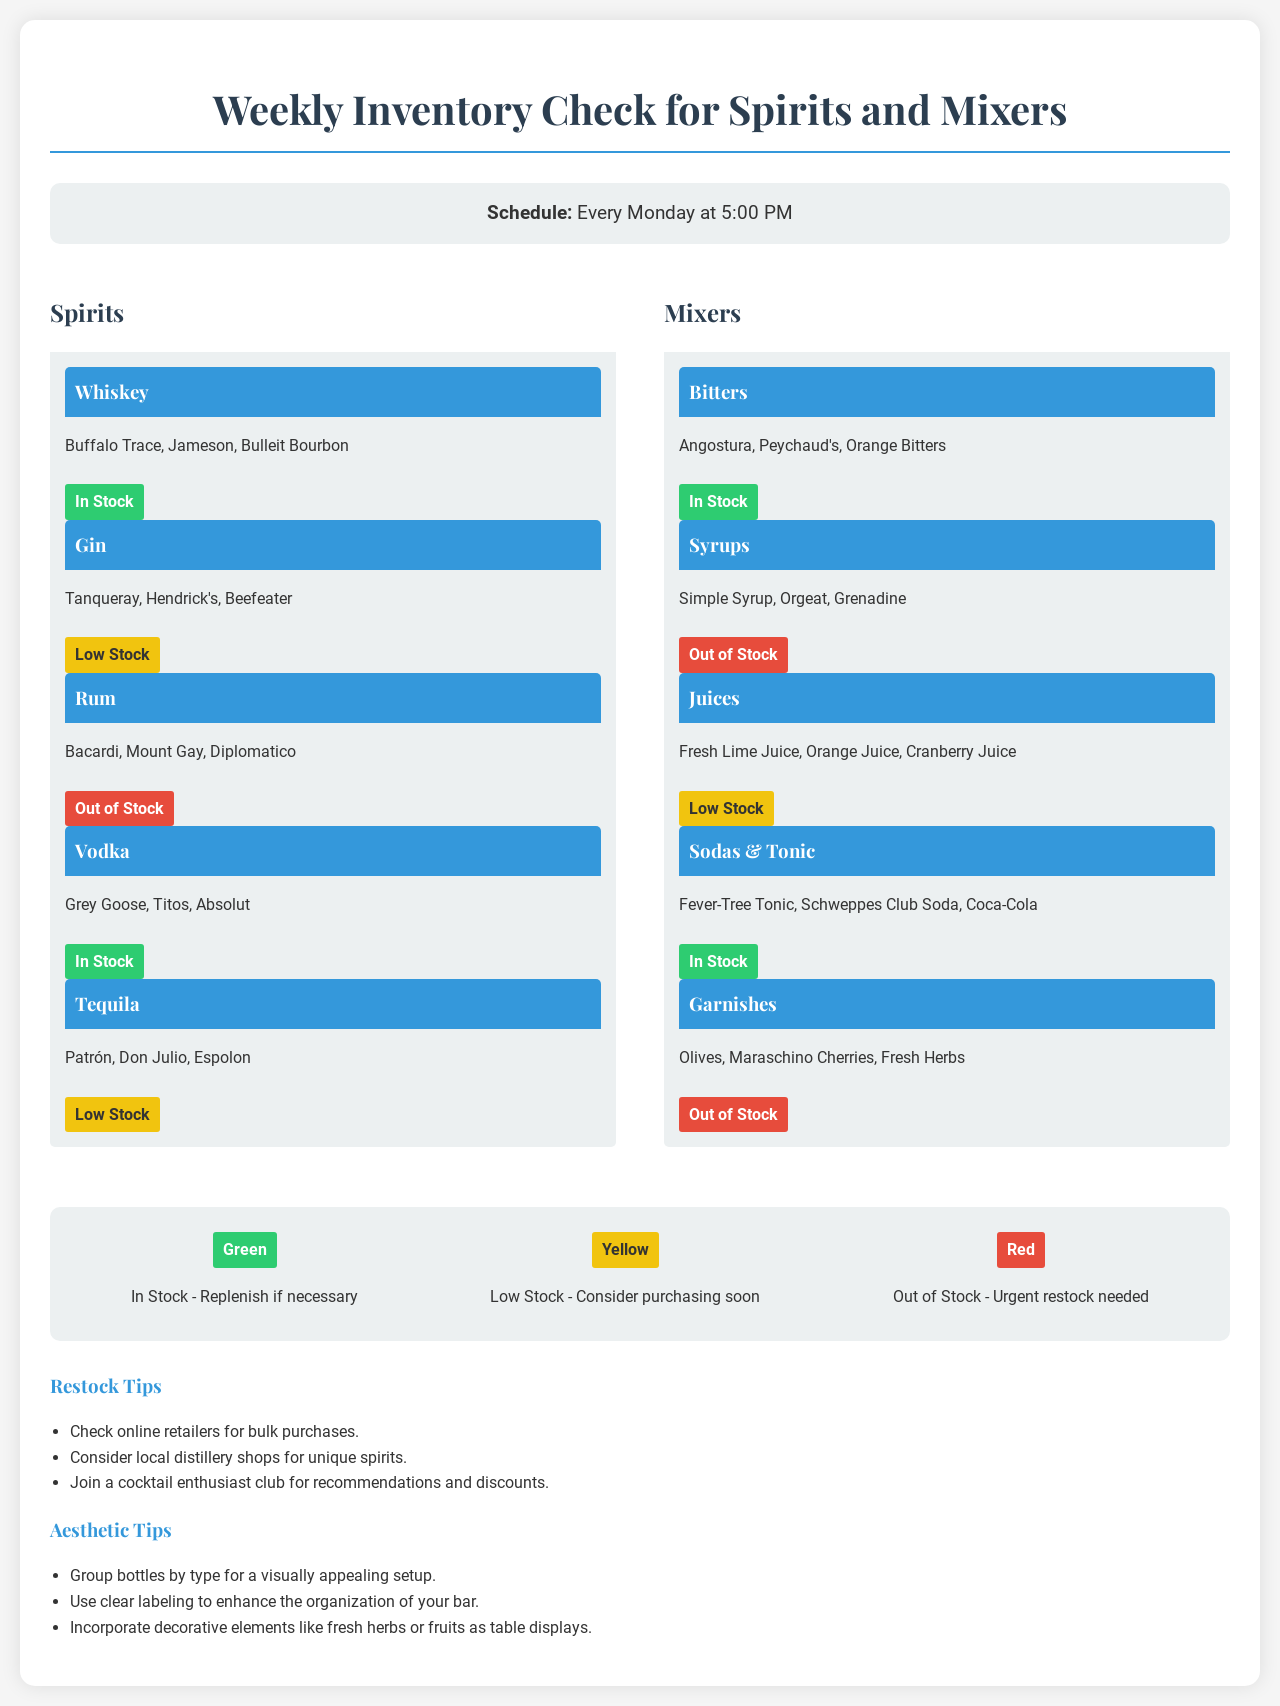What day and time is the inventory check scheduled? The inventory check is scheduled for every Monday at 5:00 PM, as noted in the schedule section of the document.
Answer: Every Monday at 5:00 PM How many whiskey brands are listed in the spirits section? The document lists three whiskey brands under the whiskey category, which are Buffalo Trace, Jameson, and Bulleit Bourbon.
Answer: 3 Which spirit category has "Out of Stock" items? The Rum category in the spirits section indicates that it is out of stock, as shown by the respective stock level color.
Answer: Rum What color represents "Low Stock"? The low stock level is represented by the yellow color, as defined in the color-coded stock levels section of the document.
Answer: Yellow Which type of mixer is currently out of stock? The document states that syrups are out of stock, highlighting this in the mixers section.
Answer: Syrups How many mixers are classified as "In Stock"? Four mixers are classified as "In Stock" in the mixers category, including Bitters, Sodas & Tonic, and others.
Answer: 4 What is recommended for purchasing unique spirits? The document suggests checking local distillery shops as a way to find unique spirits, which is noted in the restock tips section.
Answer: Local distillery shops Which category shows that both its garnishes and syrups are out of stock? The mixers category shows that both garnishes and syrups are out of stock, indicating multiple shortages in that list.
Answer: Mixers 